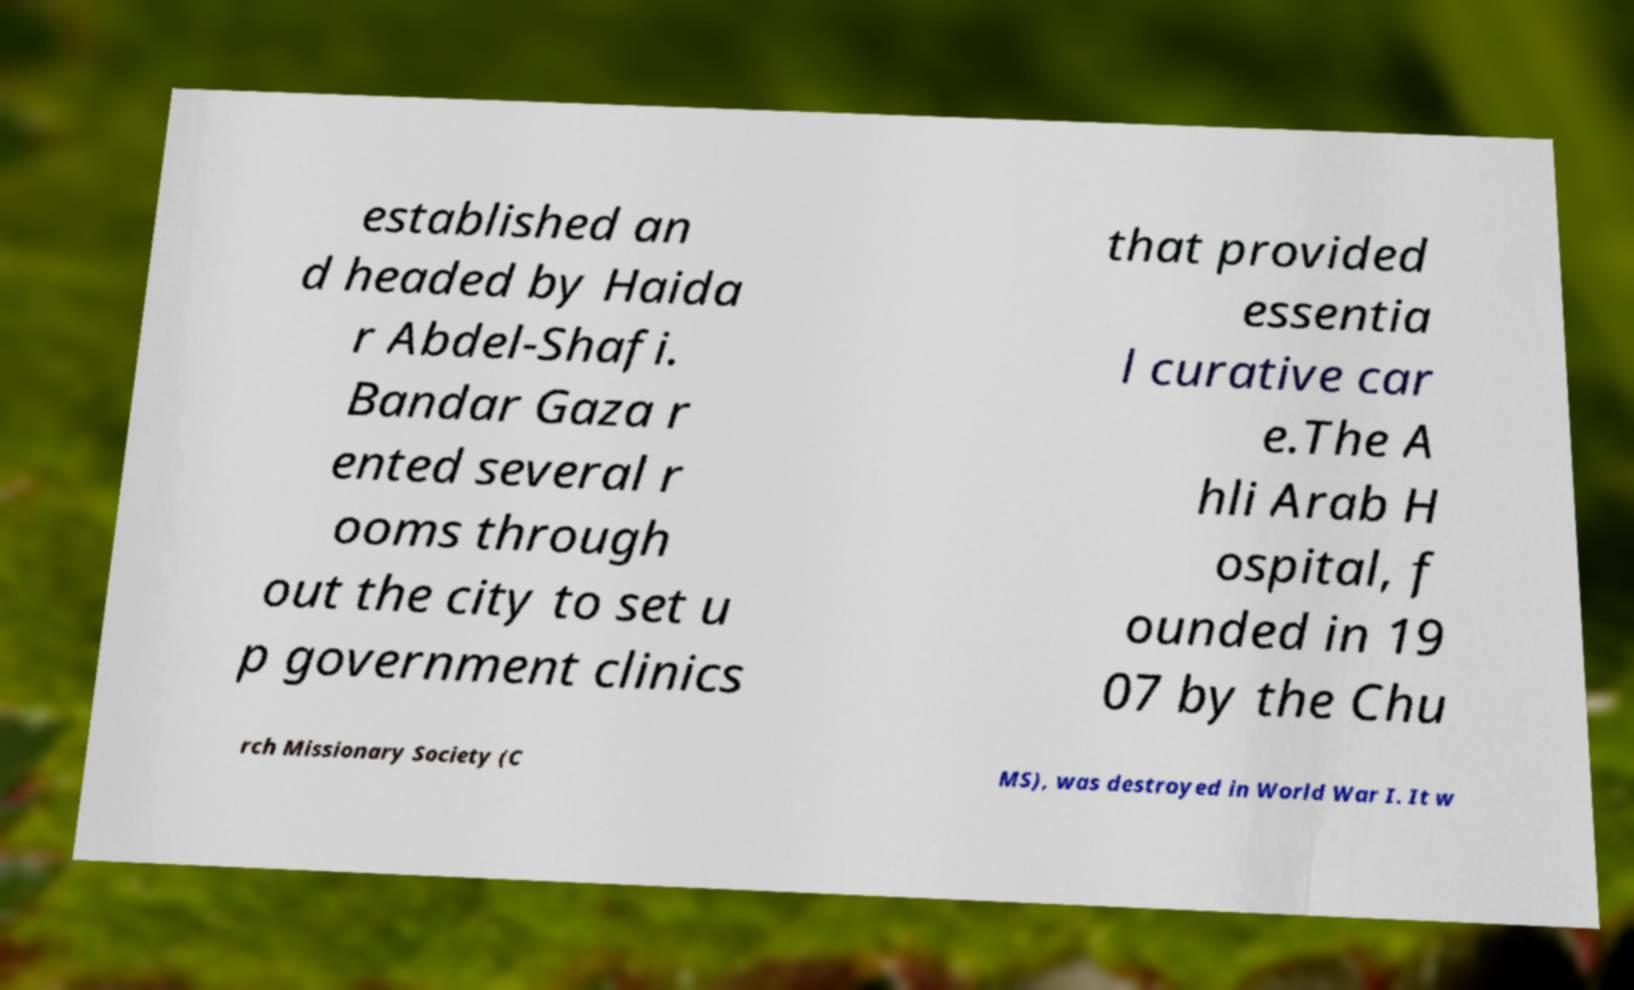For documentation purposes, I need the text within this image transcribed. Could you provide that? established an d headed by Haida r Abdel-Shafi. Bandar Gaza r ented several r ooms through out the city to set u p government clinics that provided essentia l curative car e.The A hli Arab H ospital, f ounded in 19 07 by the Chu rch Missionary Society (C MS), was destroyed in World War I. It w 